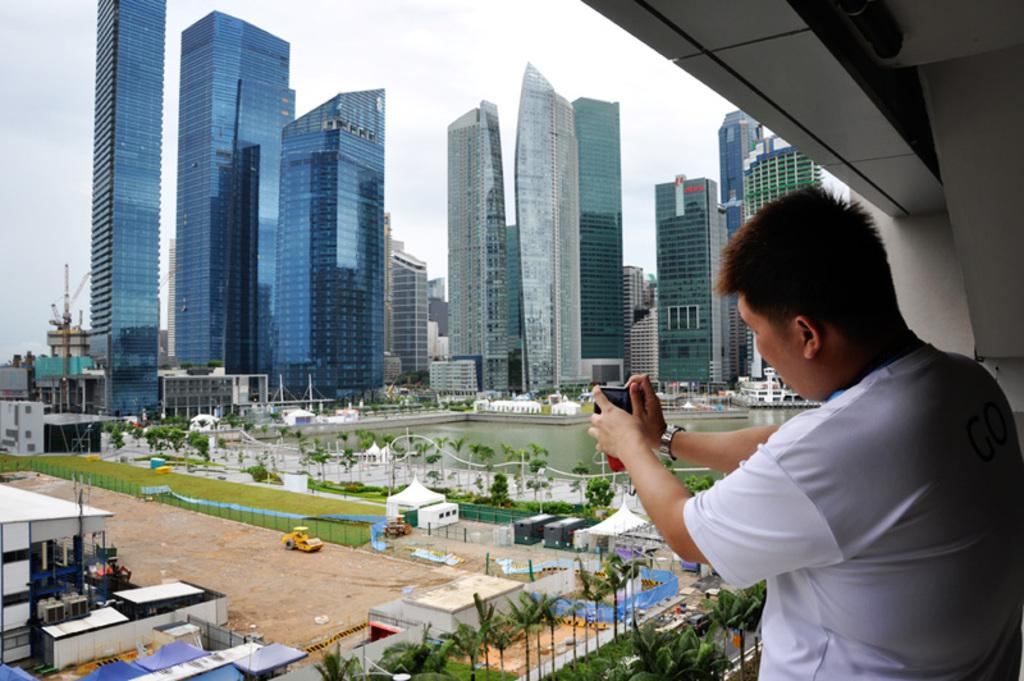Where is the person in the image located? The person is standing under the roof in the image. What is the person holding in the image? The person is holding a camera in the image. What can be seen on the ground in the image? There is a vehicle on the ground in the image. What type of natural elements are visible in the image? There are trees visible in the image. What type of man-made structures can be seen in the image? There are buildings in the image. What type of temporary shelter is present in the image? There are tents in the image. What type of water feature is visible in the image? There is water visible in the image. What type of curtain is hanging from the trees in the image? There are no curtains hanging from the trees in the image; only trees, buildings, tents, and water are present. 